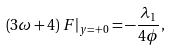Convert formula to latex. <formula><loc_0><loc_0><loc_500><loc_500>\left ( 3 \omega + 4 \right ) F | _ { y = + 0 } = - \frac { \lambda _ { 1 } } { 4 \phi } ,</formula> 